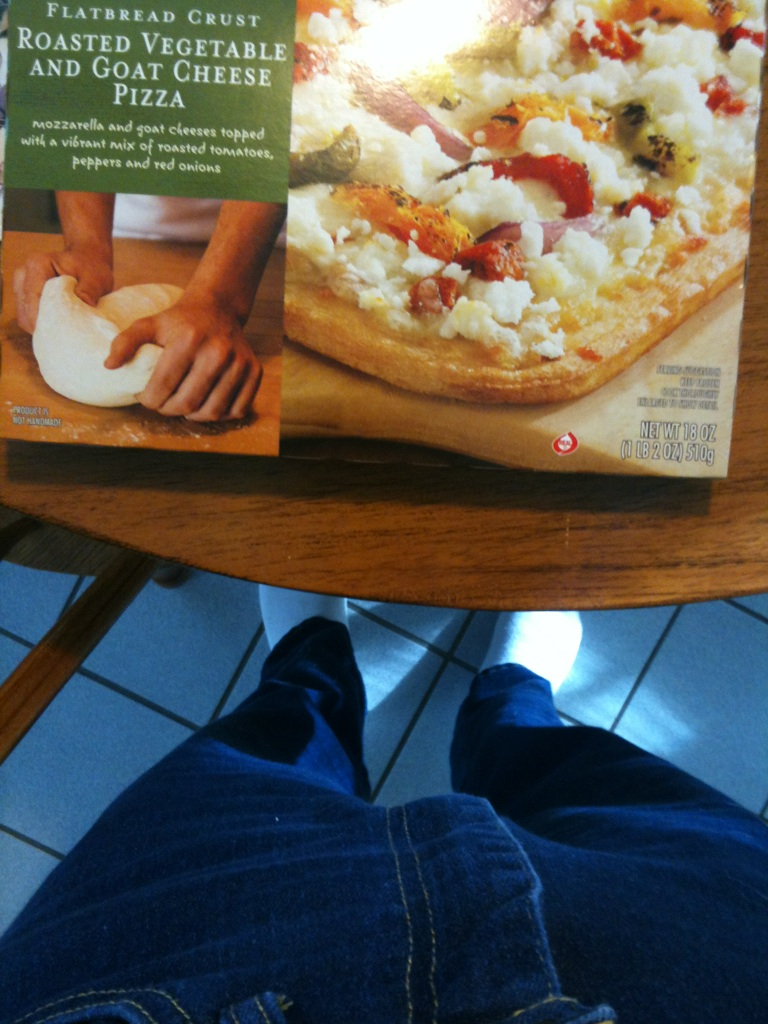Can you tell me more about the nutritional aspects of this pizza? Certainly! This pizza combines a healthy serving of vegetables on a lighter flatbread crust, which is usually lower in calories compared to traditional pizza crusts. The goat cheese adds a good source of protein and calcium, but it's also lighter in fat than most other cheeses. Is this pizza suitable for vegetarians? Yes, this roasted vegetable and goat cheese pizza is suitable for vegetarians. It contains no meat products, making it a great option for those following a vegetarian diet. 